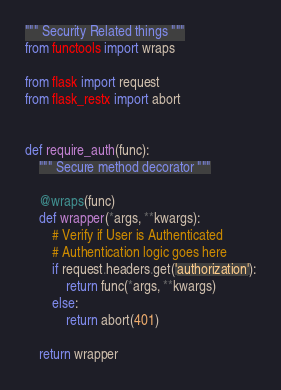<code> <loc_0><loc_0><loc_500><loc_500><_Python_>""" Security Related things """
from functools import wraps

from flask import request
from flask_restx import abort


def require_auth(func):
    """ Secure method decorator """

    @wraps(func)
    def wrapper(*args, **kwargs):
        # Verify if User is Authenticated
        # Authentication logic goes here
        if request.headers.get('authorization'):
            return func(*args, **kwargs)
        else:
            return abort(401)

    return wrapper
</code> 